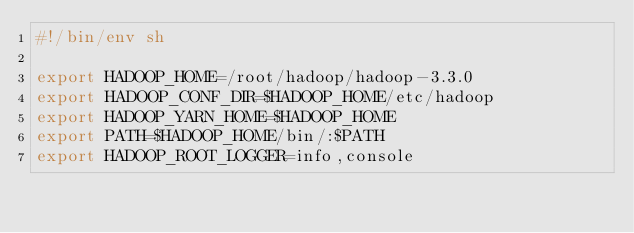<code> <loc_0><loc_0><loc_500><loc_500><_Bash_>#!/bin/env sh

export HADOOP_HOME=/root/hadoop/hadoop-3.3.0
export HADOOP_CONF_DIR=$HADOOP_HOME/etc/hadoop
export HADOOP_YARN_HOME=$HADOOP_HOME
export PATH=$HADOOP_HOME/bin/:$PATH
export HADOOP_ROOT_LOGGER=info,console
</code> 